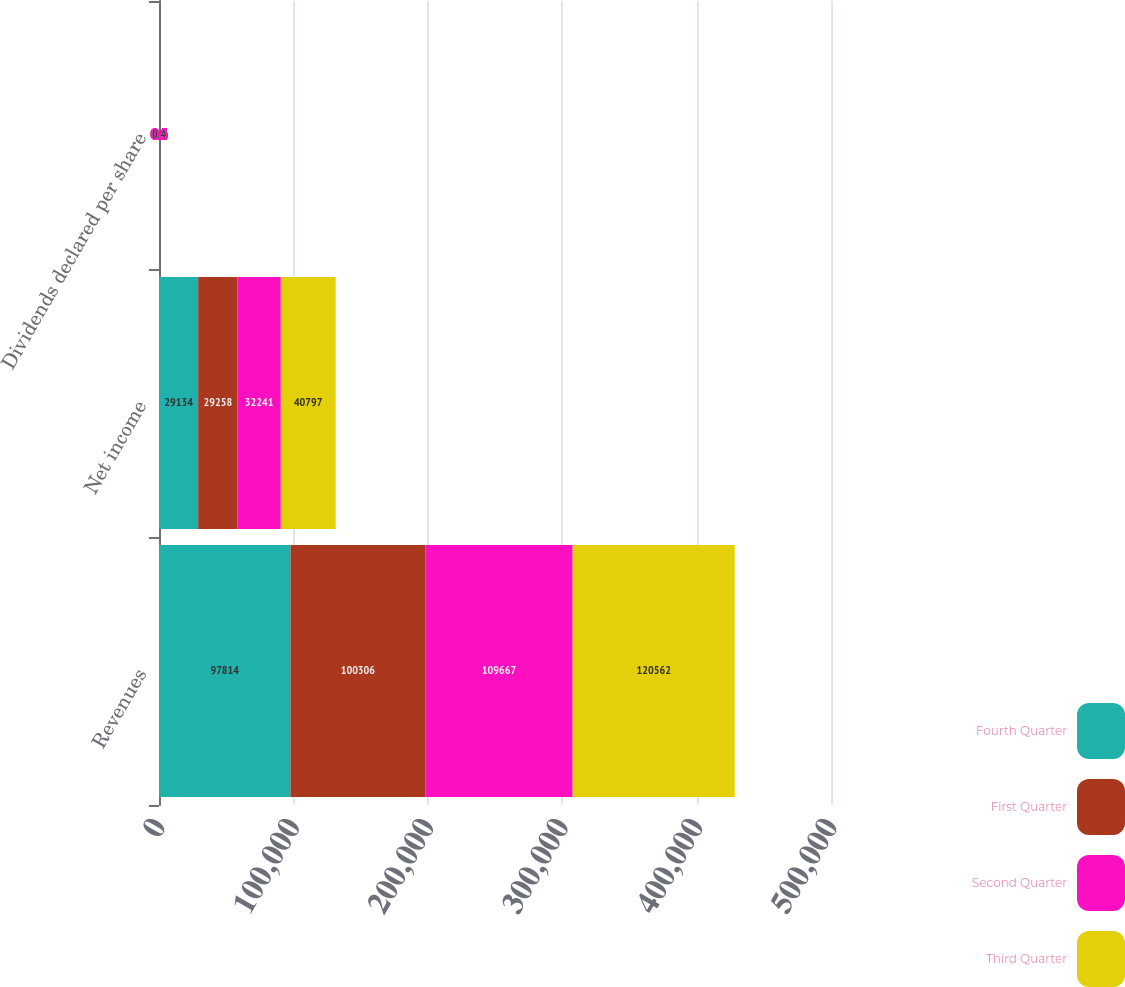Convert chart to OTSL. <chart><loc_0><loc_0><loc_500><loc_500><stacked_bar_chart><ecel><fcel>Revenues<fcel>Net income<fcel>Dividends declared per share<nl><fcel>Fourth Quarter<fcel>97814<fcel>29134<fcel>0.4<nl><fcel>First Quarter<fcel>100306<fcel>29258<fcel>0.4<nl><fcel>Second Quarter<fcel>109667<fcel>32241<fcel>0.4<nl><fcel>Third Quarter<fcel>120562<fcel>40797<fcel>0.4<nl></chart> 